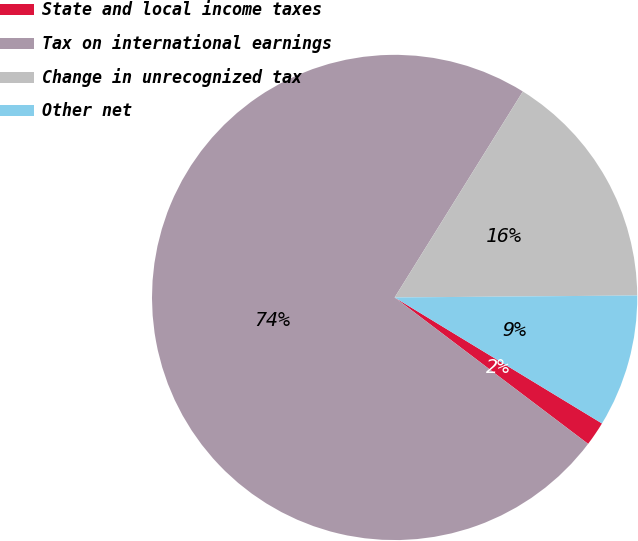Convert chart. <chart><loc_0><loc_0><loc_500><loc_500><pie_chart><fcel>State and local income taxes<fcel>Tax on international earnings<fcel>Change in unrecognized tax<fcel>Other net<nl><fcel>1.62%<fcel>73.55%<fcel>16.01%<fcel>8.82%<nl></chart> 